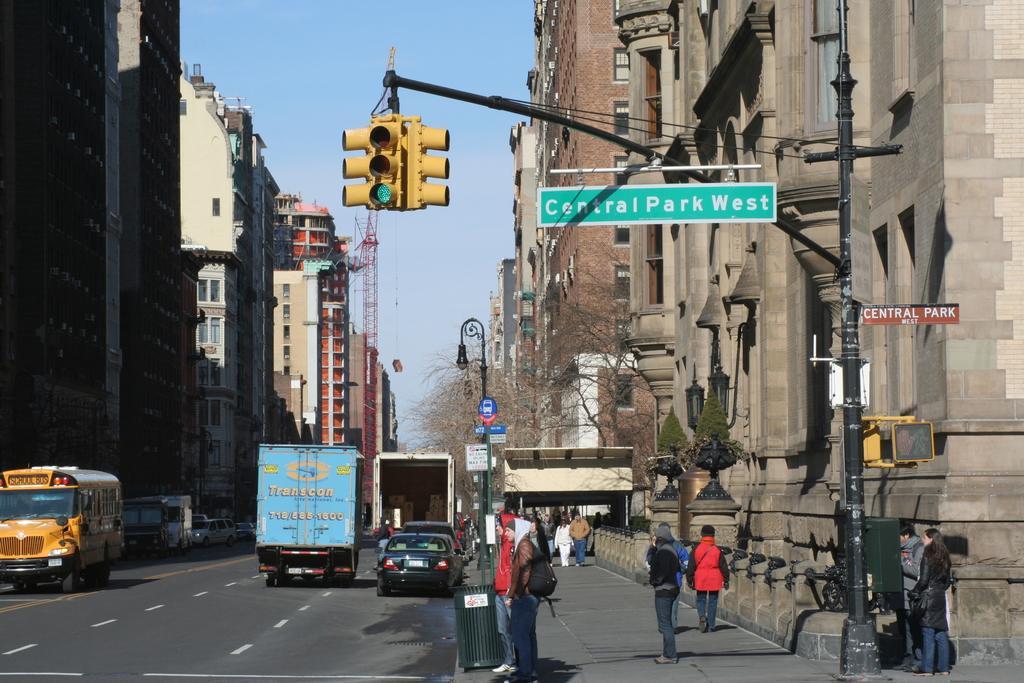Can you describe this image briefly? This picture consists of a road , on the road I can see vehicles on the right side I can see the building , in front of the building I can see there are few persons walking and standing on the divider and I can see a traffic signal light visible in front of the building and on the left side i can see few buildings, on the top I can see the sky and in the middle I can see trees. 